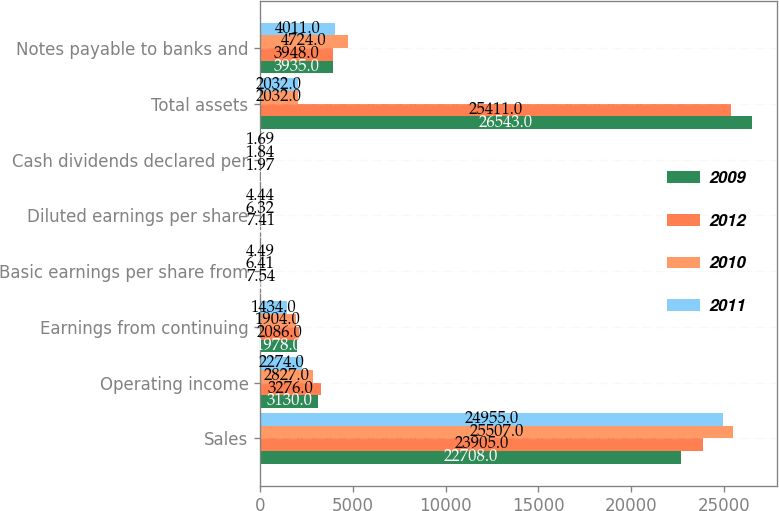Convert chart. <chart><loc_0><loc_0><loc_500><loc_500><stacked_bar_chart><ecel><fcel>Sales<fcel>Operating income<fcel>Earnings from continuing<fcel>Basic earnings per share from<fcel>Diluted earnings per share<fcel>Cash dividends declared per<fcel>Total assets<fcel>Notes payable to banks and<nl><fcel>2009<fcel>22708<fcel>3130<fcel>1978<fcel>7.96<fcel>7.81<fcel>2.15<fcel>26543<fcel>3935<nl><fcel>2012<fcel>23905<fcel>3276<fcel>2086<fcel>7.54<fcel>7.41<fcel>1.97<fcel>25411<fcel>3948<nl><fcel>2010<fcel>25507<fcel>2827<fcel>1904<fcel>6.41<fcel>6.32<fcel>1.84<fcel>2032<fcel>4724<nl><fcel>2011<fcel>24955<fcel>2274<fcel>1434<fcel>4.49<fcel>4.44<fcel>1.69<fcel>2032<fcel>4011<nl></chart> 